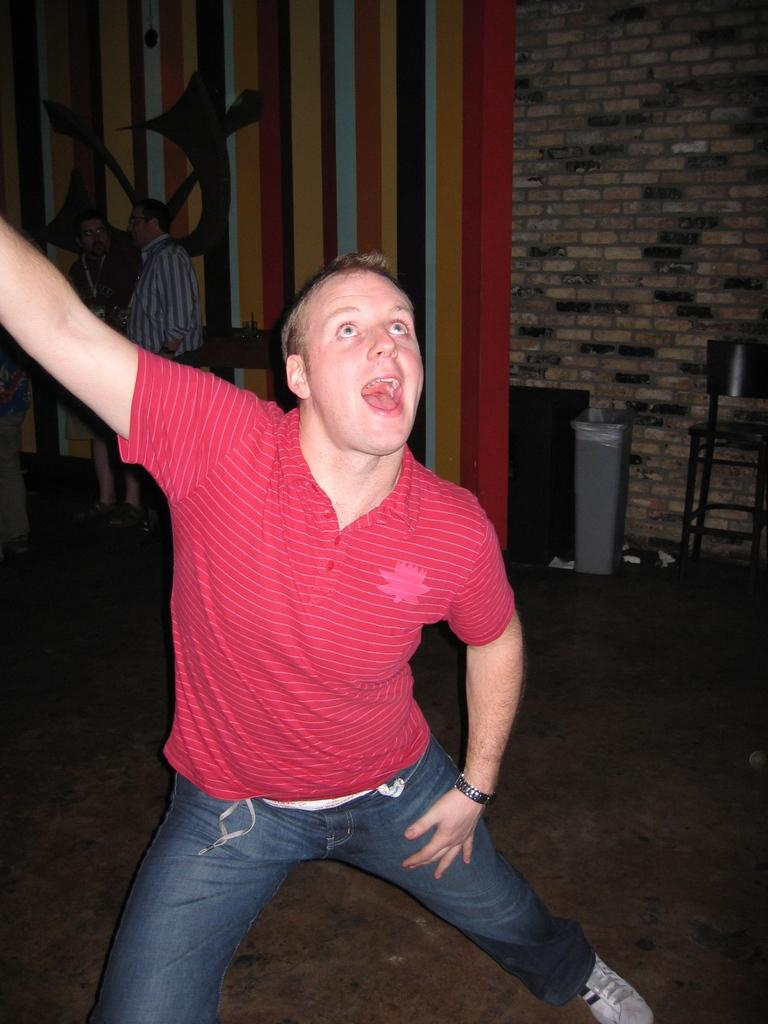Who is the main subject in the image? There is a man in the center of the image. What can be seen in the background of the image? There are other people, stands, a board, and a wall visible in the background of the image. What is the surface on which the man and other elements are placed? There is a floor at the bottom of the image. What direction is the bubble floating in the image? There is no bubble present in the image. Can you tell me the relationship between the man and the person in the background? The provided facts do not give any information about the relationship between the man and the people in the background. 